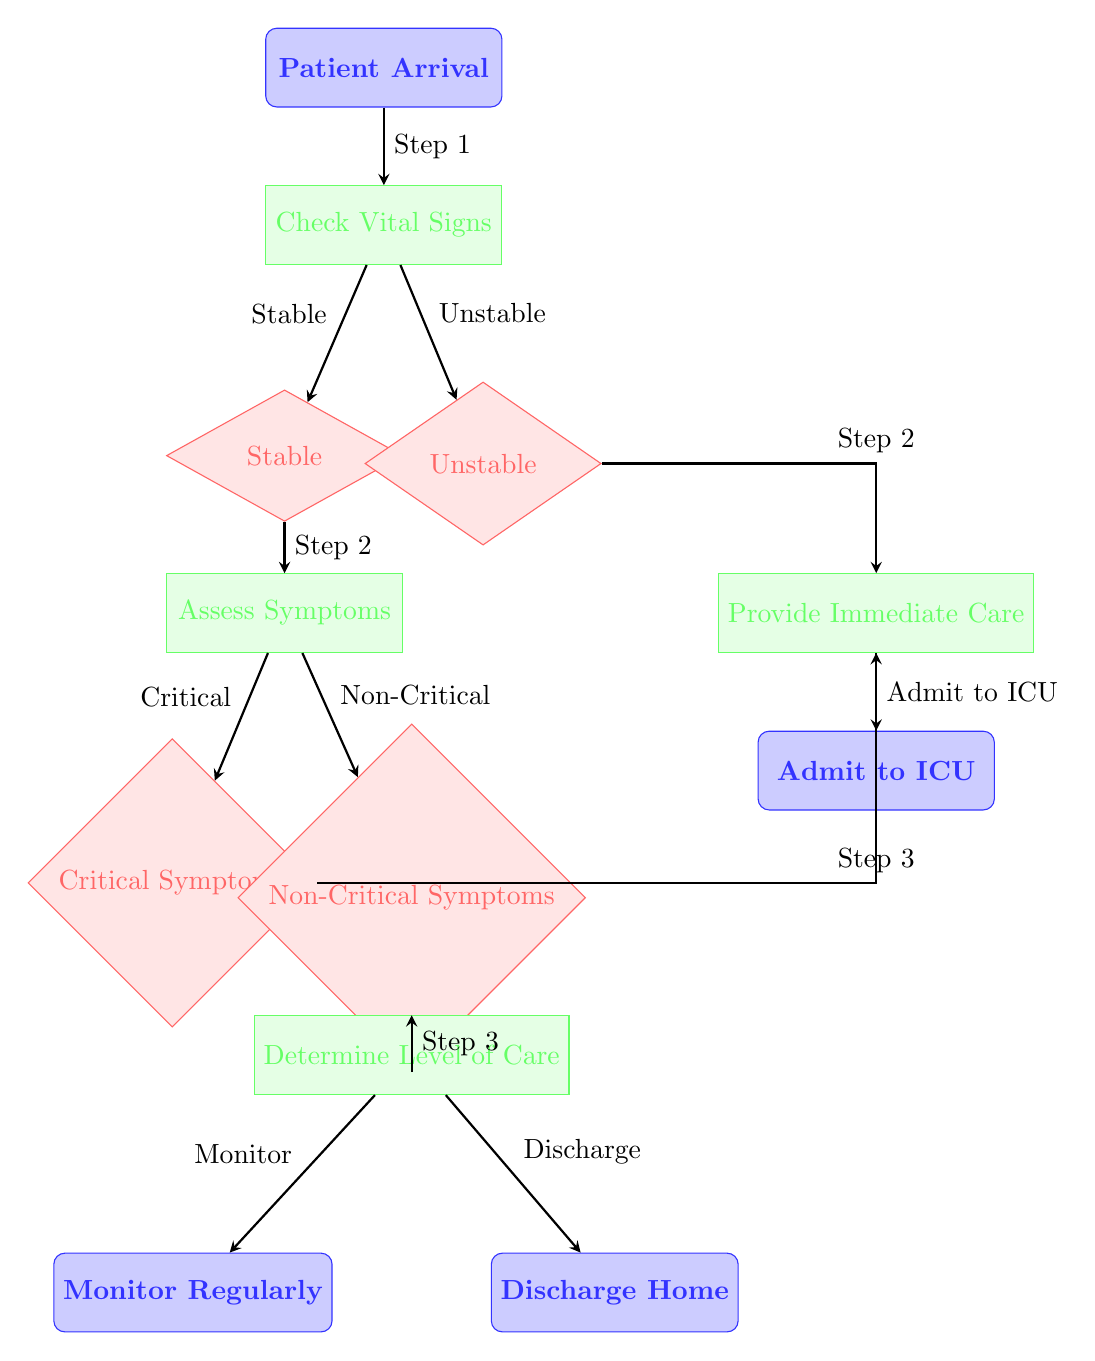What's the first step after patient arrival? The flowchart shows that the first step after patient arrival is to check vital signs. This is indicated by the arrow leading from "Patient Arrival" to "Check Vital Signs."
Answer: Check Vital Signs How many decision nodes are in the diagram? The diagram contains three decision nodes: "Stable," "Unstable," and "Critical Symptoms." Each decision node is clearly marked and indicates points where a choice is made.
Answer: Three What action is taken if the patient is unstable? According to the flowchart, if the patient is unstable, the next action is to provide immediate care. This is shown by the arrow leading directly from "Unstable" to "Provide Immediate Care."
Answer: Provide Immediate Care What do you do after assessing symptoms if they are non-critical? The flowchart indicates that after assessing symptoms and finding them non-critical, the next step is to determine the level of care. This is shown by the arrow leading from "Non-Critical Symptoms" to "Determine Level of Care."
Answer: Determine Level of Care Which step involves admitting the patient to ICU? The step involving admitting the patient to the ICU occurs after providing immediate care. The flowchart shows an arrow leading from "Provide Immediate Care" directly to "Admit to ICU."
Answer: Admit to ICU What happens if the symptoms are critical? If the symptoms are critical, as indicated by the diagram, immediate care is provided to the patient. The flow shows an arrow leading from "Critical Symptoms" to "Provide Immediate Care."
Answer: Provide Immediate Care Where does monitoring take place in the flowchart? Monitoring takes place after determining the level of care when the patient is non-critical. The arrow in the diagram leads from "Determine Level of Care" to "Monitor Regularly."
Answer: Monitor Regularly What is the action taken for stable patients after checking vital signs? For stable patients, the next action after checking vital signs is to assess symptoms. This is indicated by the arrow leading from "Stable" to "Assess Symptoms."
Answer: Assess Symptoms 